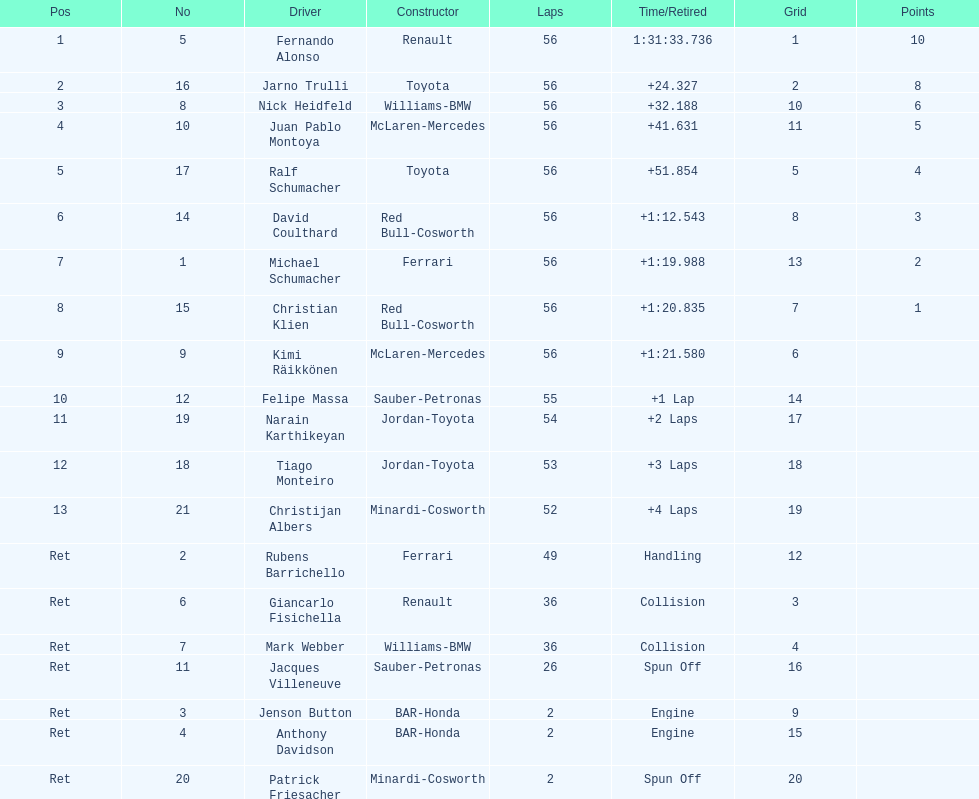Who was the ultimate driver to truly finish the race? Christijan Albers. 